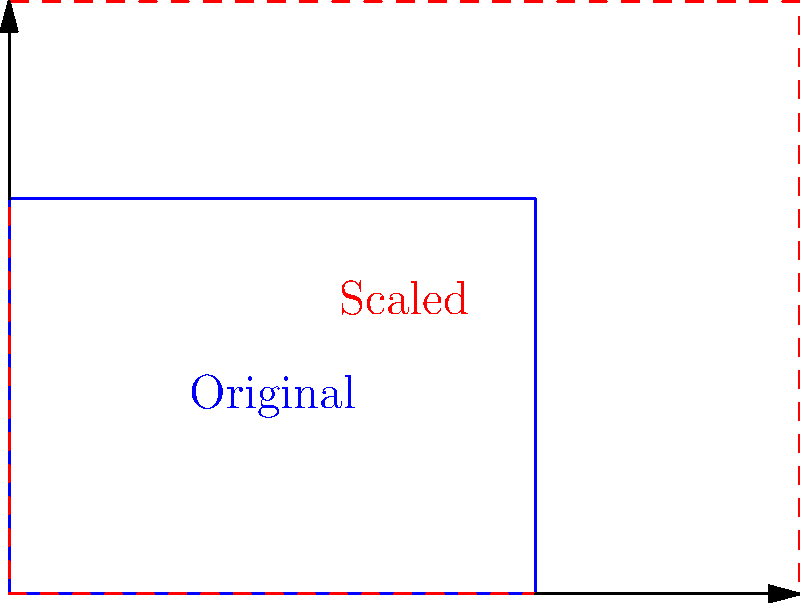A cylindrical containment structure for a nuclear reactor has a diameter of 40 meters and a height of 30 meters. Due to new safety regulations, the structure needs to be scaled up while maintaining its proportions. If the new diameter is required to be 60 meters, what will be the new height of the containment structure? How does this scaling factor relate to potential changes in the structure's volume capacity for containing radioactive materials in the event of an accident? To solve this problem, we'll follow these steps:

1) First, let's identify the scaling factor:
   New diameter / Original diameter = Scaling factor
   $60 \text{ m} / 40 \text{ m} = 1.5$

2) Since we're maintaining proportions, this scaling factor applies to all dimensions:
   New height = Original height × Scaling factor
   New height = $30 \text{ m} \times 1.5 = 45 \text{ m}$

3) To understand the impact on volume capacity, we need to calculate how the volume scales:
   Volume scales with the cube of the linear scaling factor.
   Volume scaling = $(1.5)^3 = 3.375$

4) This means the new volume will be 3.375 times the original volume.

5) We can verify this:
   Original volume: $V_1 = \pi r^2 h = \pi (20 \text{ m})^2 (30 \text{ m}) = 37,699 \text{ m}^3$
   New volume: $V_2 = \pi r^2 h = \pi (30 \text{ m})^2 (45 \text{ m}) = 127,235 \text{ m}^3$
   $V_2 / V_1 = 127,235 / 37,699 = 3.375$

This significant increase in volume capacity (237.5% more) could greatly enhance the structure's ability to contain radioactive materials in case of an accident, potentially improving safety margins and reducing the risk of environmental contamination.
Answer: 45 meters; 3.375 times increase in volume capacity 